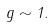Convert formula to latex. <formula><loc_0><loc_0><loc_500><loc_500>g \sim 1 .</formula> 